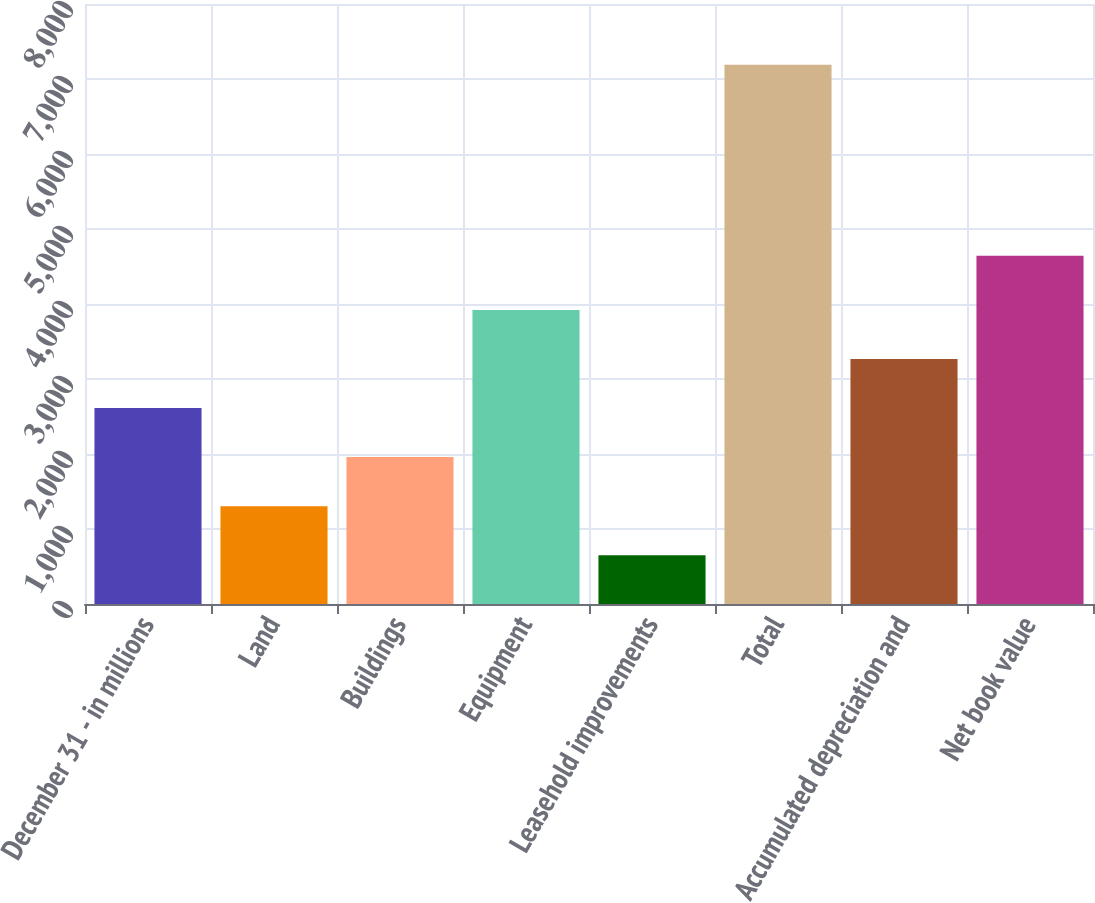Convert chart to OTSL. <chart><loc_0><loc_0><loc_500><loc_500><bar_chart><fcel>December 31 - in millions<fcel>Land<fcel>Buildings<fcel>Equipment<fcel>Leasehold improvements<fcel>Total<fcel>Accumulated depreciation and<fcel>Net book value<nl><fcel>2612.7<fcel>1304.9<fcel>1958.8<fcel>3920.5<fcel>651<fcel>7190<fcel>3266.6<fcel>4644<nl></chart> 